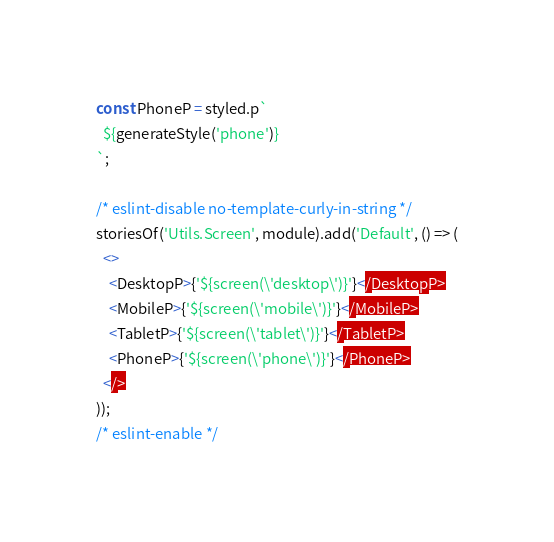Convert code to text. <code><loc_0><loc_0><loc_500><loc_500><_JavaScript_>const PhoneP = styled.p`
  ${generateStyle('phone')}
`;

/* eslint-disable no-template-curly-in-string */
storiesOf('Utils.Screen', module).add('Default', () => (
  <>
    <DesktopP>{'${screen(\'desktop\')}'}</DesktopP>
    <MobileP>{'${screen(\'mobile\')}'}</MobileP>
    <TabletP>{'${screen(\'tablet\')}'}</TabletP>
    <PhoneP>{'${screen(\'phone\')}'}</PhoneP>
  </>
));
/* eslint-enable */
</code> 